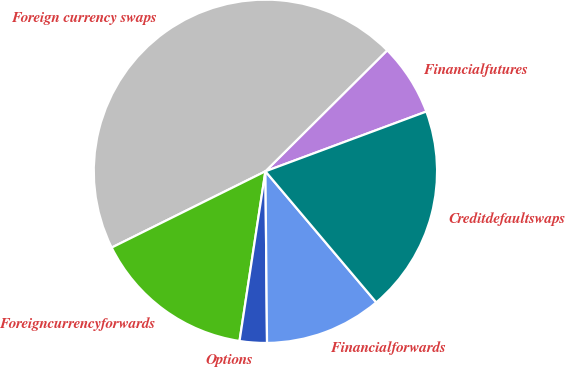<chart> <loc_0><loc_0><loc_500><loc_500><pie_chart><fcel>Financialfutures<fcel>Foreign currency swaps<fcel>Foreigncurrencyforwards<fcel>Options<fcel>Financialforwards<fcel>Creditdefaultswaps<nl><fcel>6.79%<fcel>44.88%<fcel>15.26%<fcel>2.56%<fcel>11.02%<fcel>19.49%<nl></chart> 